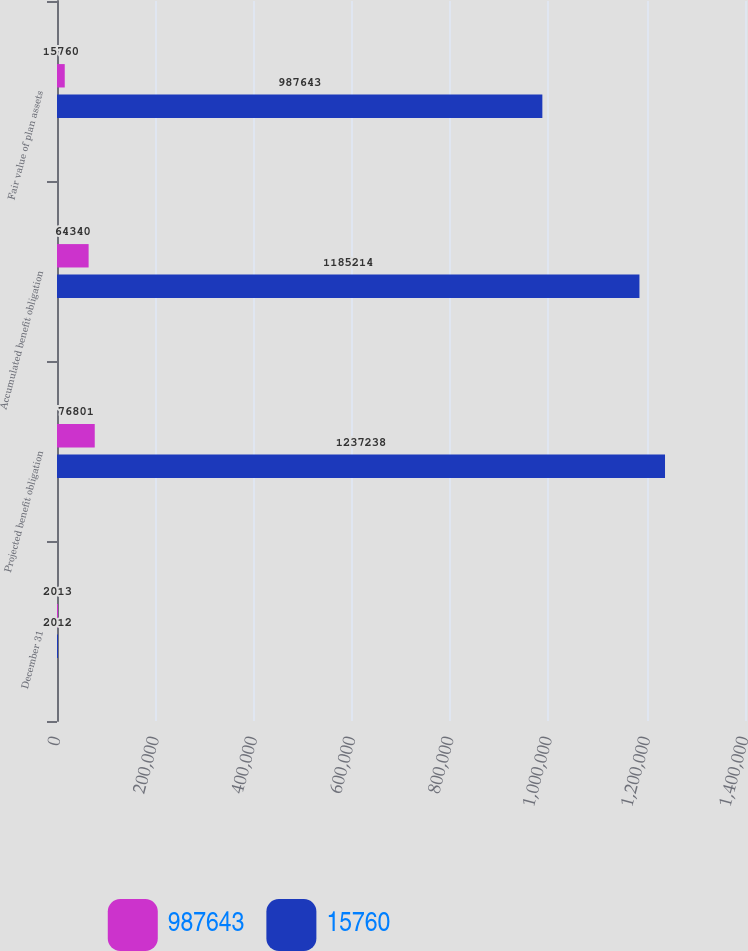<chart> <loc_0><loc_0><loc_500><loc_500><stacked_bar_chart><ecel><fcel>December 31<fcel>Projected benefit obligation<fcel>Accumulated benefit obligation<fcel>Fair value of plan assets<nl><fcel>987643<fcel>2013<fcel>76801<fcel>64340<fcel>15760<nl><fcel>15760<fcel>2012<fcel>1.23724e+06<fcel>1.18521e+06<fcel>987643<nl></chart> 